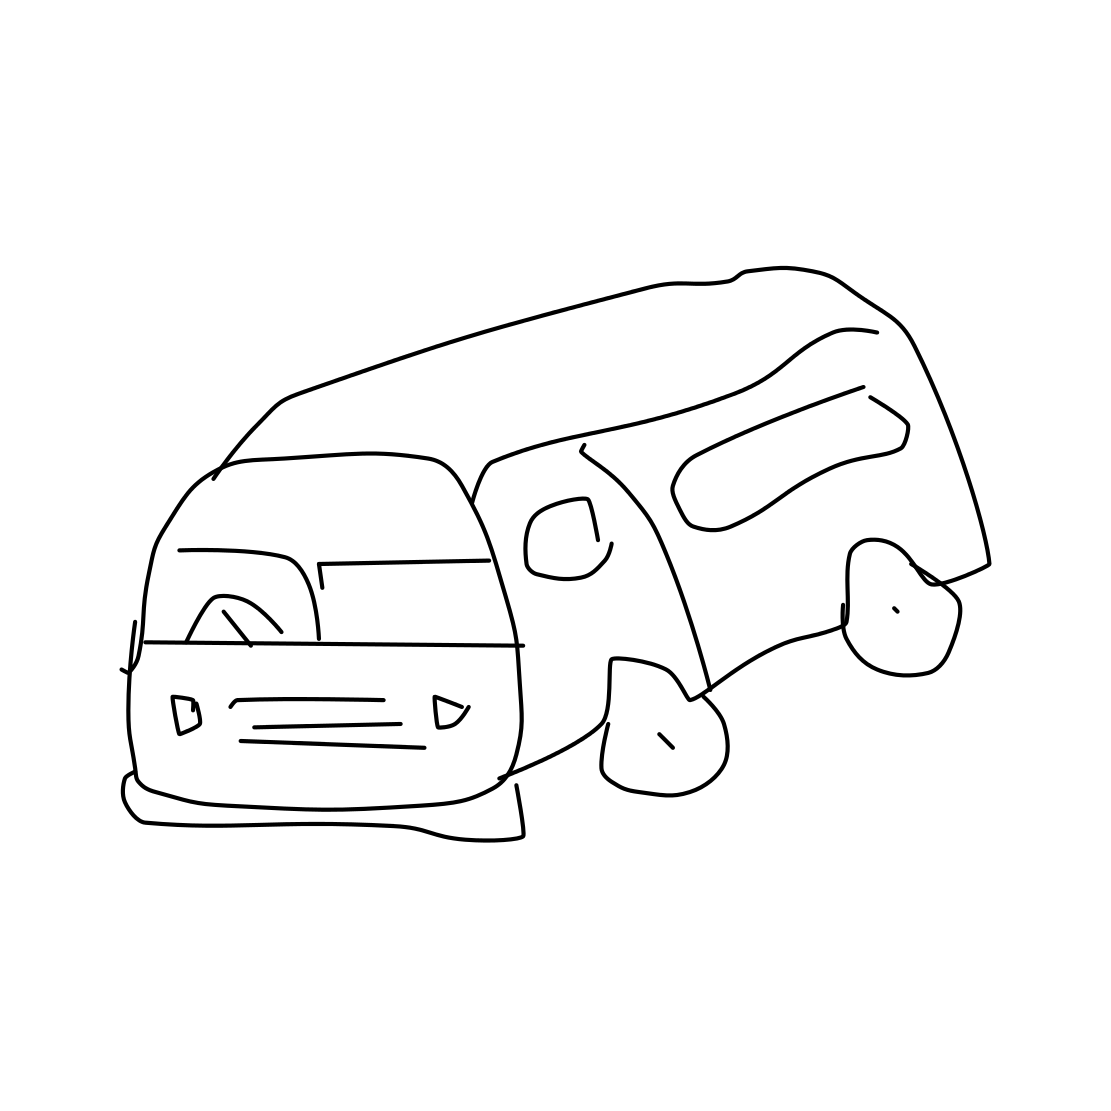What might this van be used for, judging by its shape and design? Based on the van's shape and design in the drawing, which features an extended body and space that suggests ample interior room, it could be used for a variety of purposes, such as a delivery vehicle, a family camper for road trips, or even as a work or utility vehicle. 